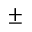Convert formula to latex. <formula><loc_0><loc_0><loc_500><loc_500>\pm</formula> 